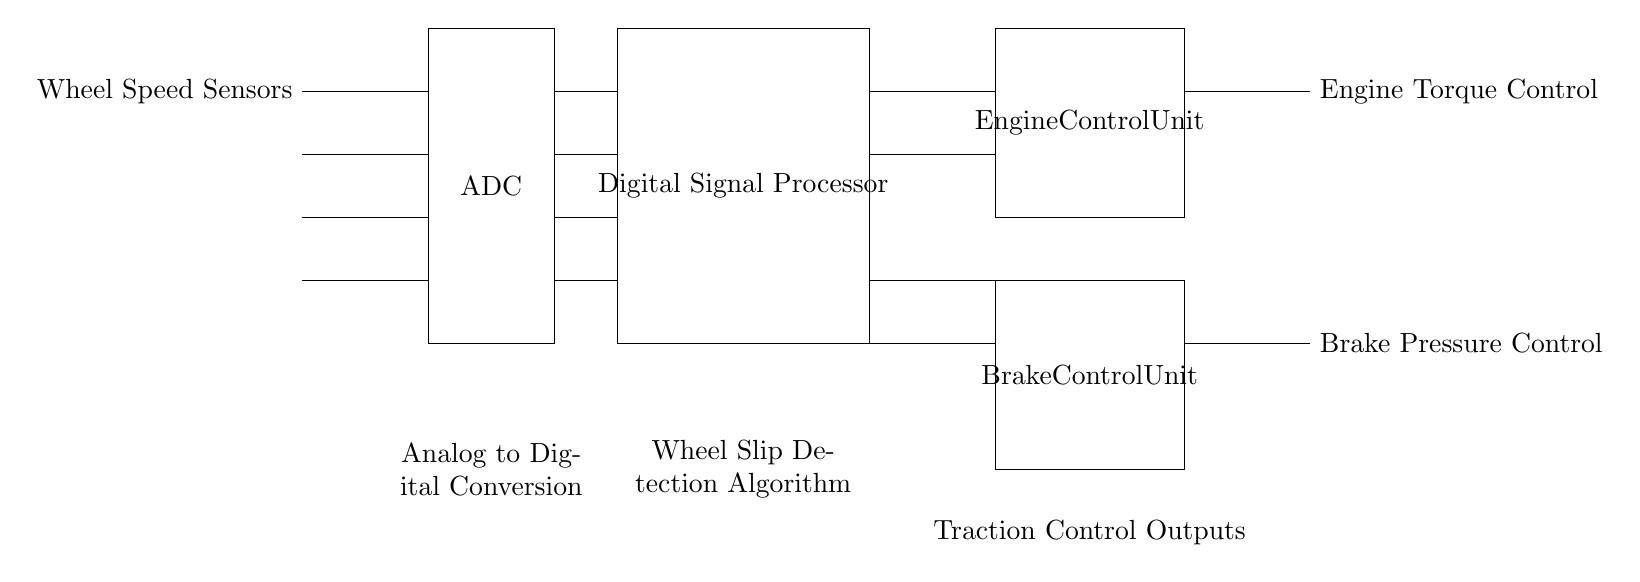What components are used for wheel slip detection? The components used for wheel slip detection include Wheel Speed Sensors, an Analog to Digital Converter (ADC), and a Digital Signal Processor (DSP) as seen at the leftmost part of the diagram where the sensors are connected.
Answer: Wheel Speed Sensors, ADC, DSP What type of control units are present in the circuit? The circuit diagram contains two types of control units: an Engine Control Unit (ECU) and a Brake Control Unit (BCU), which are positioned on the right side of the diagram.
Answer: Engine Control Unit, Brake Control Unit Which unit processes the digital signals from the ADC? The digital signals from the ADC are processed by the Digital Signal Processor (DSP), as indicated by the direct connection from the ADC to the DSP in the circuit.
Answer: Digital Signal Processor What outputs does the traction control system provide? The traction control system provides two outputs: Engine Torque Control and Brake Pressure Control, which are noted at the far right of the diagram connected to the respective control units.
Answer: Engine Torque Control, Brake Pressure Control How does the DSP receive data in this circuit? The DSP receives data through connections from the ADC, which convert the analog signals from the Wheel Speed Sensors into digital format for processing, as shown by the lines between the ADC and DSP.
Answer: Through connections from the ADC What is the purpose of the ADC in the traction control system? The ADC's purpose in the traction control system is to convert the analog signals from the Wheel Speed Sensors into digital signals, allowing the DSP to analyze the data for wheel slip detection.
Answer: Convert analog to digital signals 